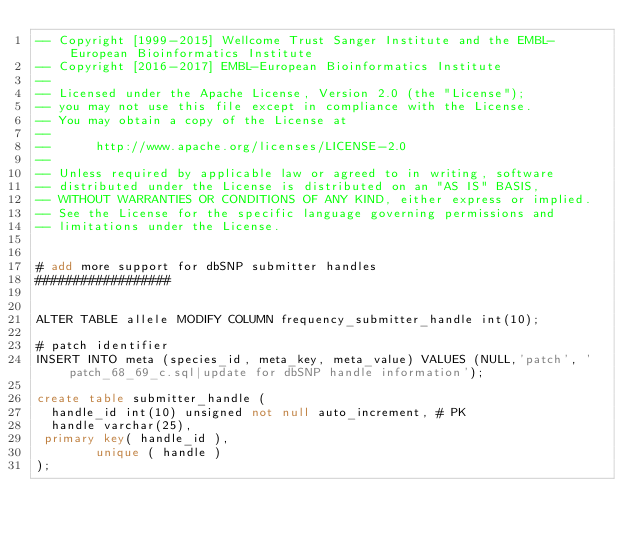Convert code to text. <code><loc_0><loc_0><loc_500><loc_500><_SQL_>-- Copyright [1999-2015] Wellcome Trust Sanger Institute and the EMBL-European Bioinformatics Institute
-- Copyright [2016-2017] EMBL-European Bioinformatics Institute
-- 
-- Licensed under the Apache License, Version 2.0 (the "License");
-- you may not use this file except in compliance with the License.
-- You may obtain a copy of the License at
-- 
--      http://www.apache.org/licenses/LICENSE-2.0
-- 
-- Unless required by applicable law or agreed to in writing, software
-- distributed under the License is distributed on an "AS IS" BASIS,
-- WITHOUT WARRANTIES OR CONDITIONS OF ANY KIND, either express or implied.
-- See the License for the specific language governing permissions and
-- limitations under the License.


# add more support for dbSNP submitter handles
##################


ALTER TABLE allele MODIFY COLUMN frequency_submitter_handle int(10);

# patch identifier
INSERT INTO meta (species_id, meta_key, meta_value) VALUES (NULL,'patch', 'patch_68_69_c.sql|update for dbSNP handle information');

create table submitter_handle (
  handle_id int(10) unsigned not null auto_increment, # PK 
  handle varchar(25),
 primary key( handle_id ),
        unique ( handle )
);
 
</code> 